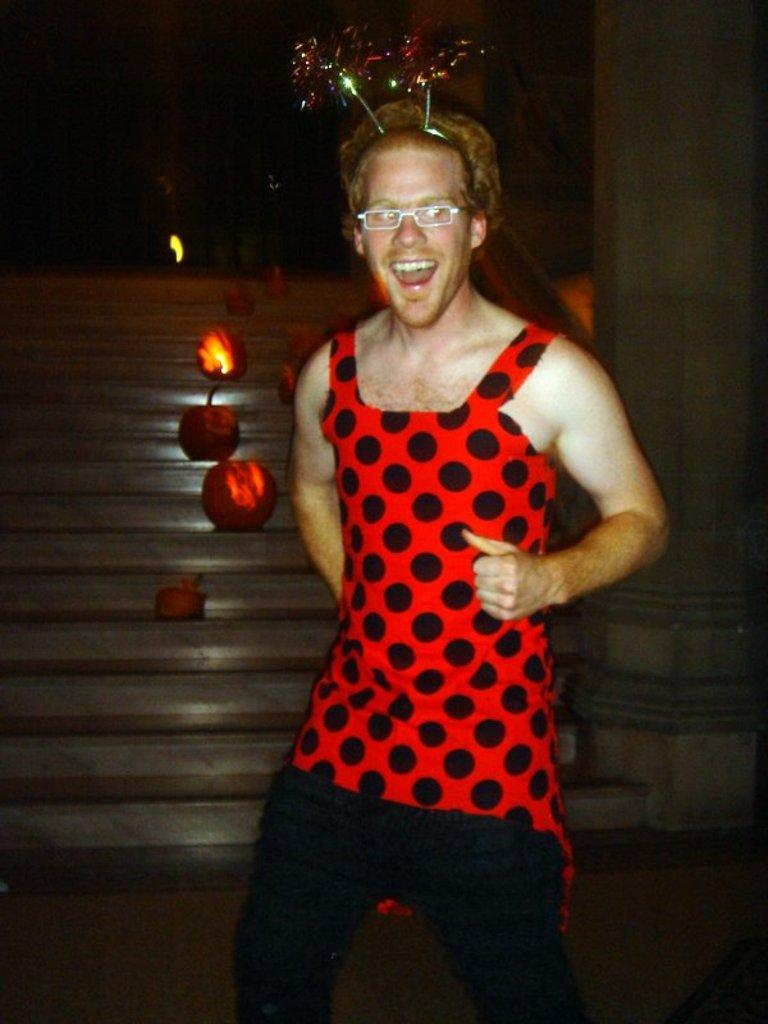What is the main subject of the image? There is a person standing in the center of the image. What can be seen in the background of the image? There are lights, stairs, and a pillar in the background of the image. How many cats are sitting on the land in the image? There are no cats or land present in the image. 